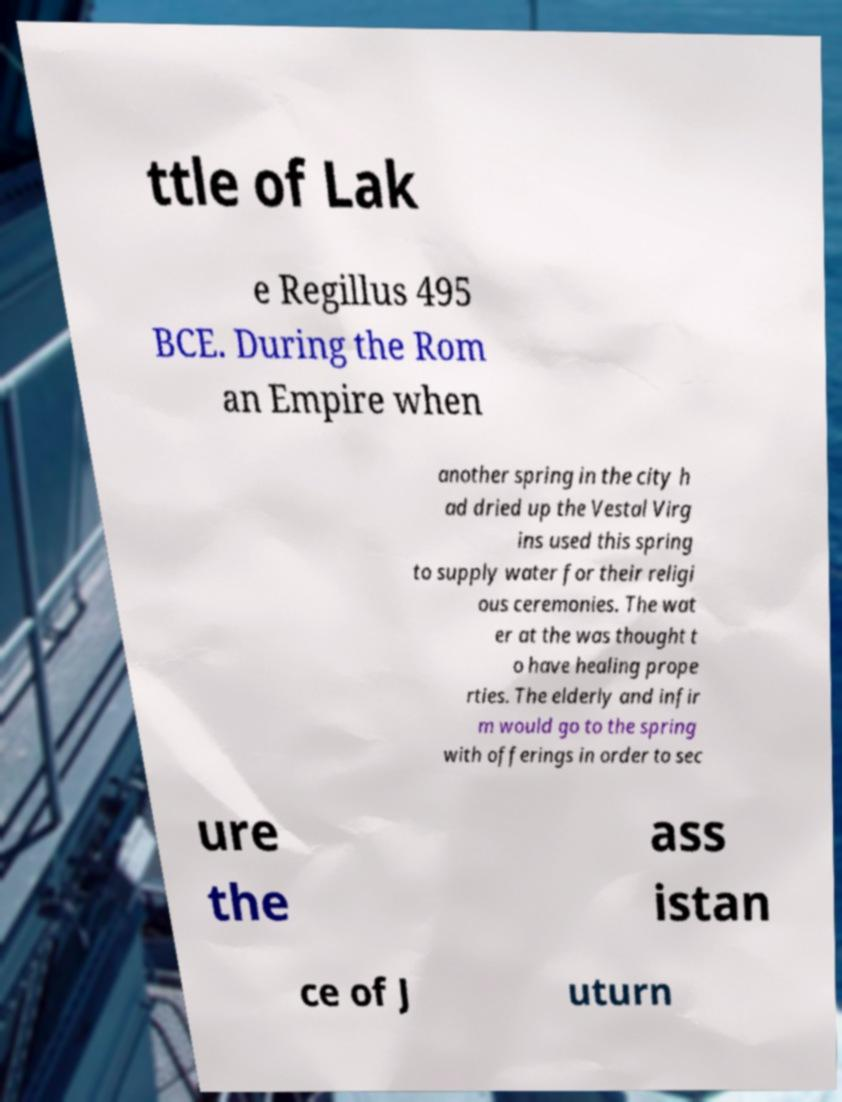Could you assist in decoding the text presented in this image and type it out clearly? ttle of Lak e Regillus 495 BCE. During the Rom an Empire when another spring in the city h ad dried up the Vestal Virg ins used this spring to supply water for their religi ous ceremonies. The wat er at the was thought t o have healing prope rties. The elderly and infir m would go to the spring with offerings in order to sec ure the ass istan ce of J uturn 